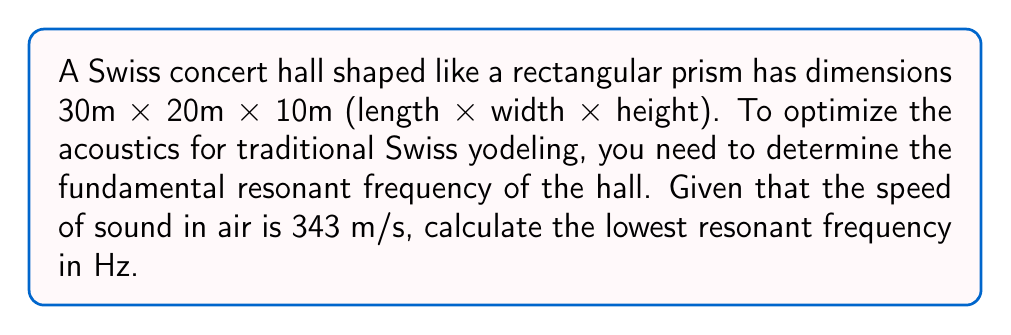Can you answer this question? To solve this problem, we'll follow these steps:

1. Recall the formula for the resonant frequencies of a rectangular room:

   $$f_{nml} = \frac{c}{2} \sqrt{\left(\frac{n}{L_x}\right)^2 + \left(\frac{m}{L_y}\right)^2 + \left(\frac{l}{L_z}\right)^2}$$

   Where:
   - $c$ is the speed of sound in air
   - $L_x$, $L_y$, and $L_z$ are the dimensions of the room
   - $n$, $m$, and $l$ are non-negative integers

2. The fundamental (lowest) frequency occurs when $n = 1$, $m = 0$, and $l = 0$. Substituting these values:

   $$f_{100} = \frac{c}{2} \sqrt{\left(\frac{1}{L_x}\right)^2 + \left(\frac{0}{L_y}\right)^2 + \left(\frac{0}{L_z}\right)^2}$$

3. Simplify:

   $$f_{100} = \frac{c}{2L_x}$$

4. Substitute the given values:
   - $c = 343$ m/s
   - $L_x = 30$ m (the longest dimension)

   $$f_{100} = \frac{343}{2 \cdot 30}$$

5. Calculate:

   $$f_{100} = 5.7166... \text{ Hz}$$

6. Round to two decimal places:

   $$f_{100} \approx 5.72 \text{ Hz}$$

This fundamental frequency is important for optimizing the acoustics of the hall for traditional Swiss yodeling, as it will affect how the low frequencies of the yodel resonate within the space.
Answer: 5.72 Hz 